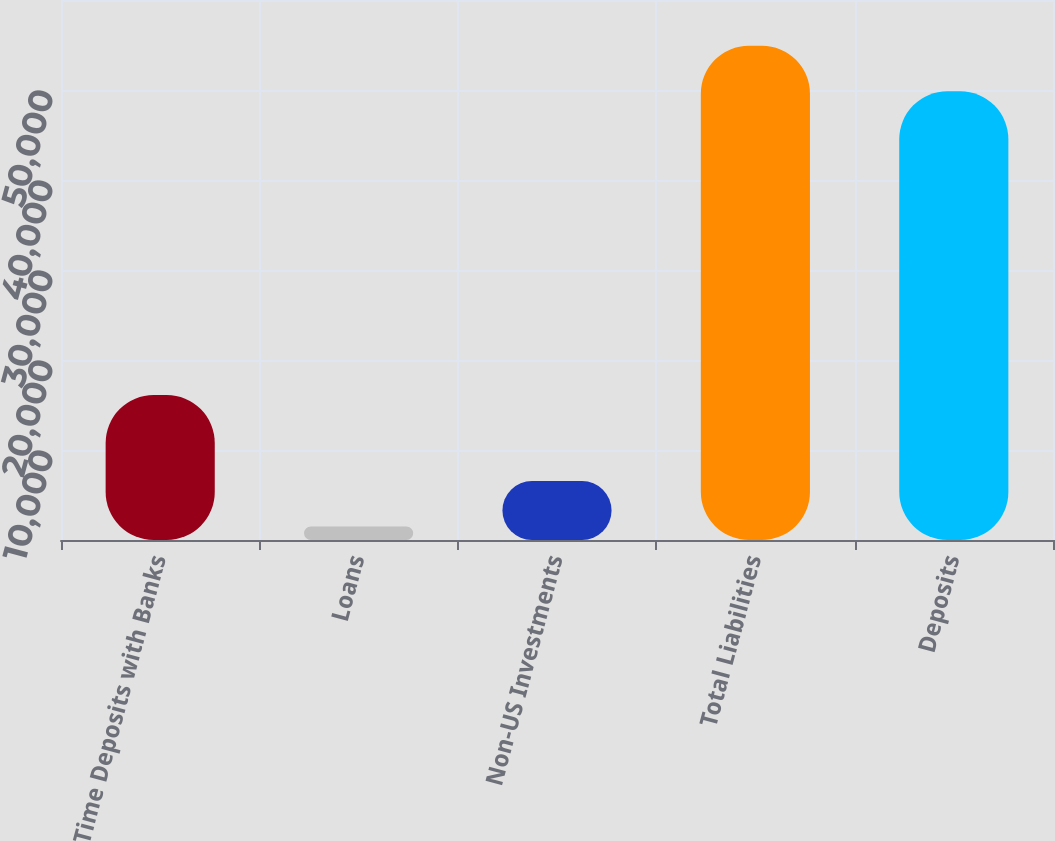Convert chart. <chart><loc_0><loc_0><loc_500><loc_500><bar_chart><fcel>Time Deposits with Banks<fcel>Loans<fcel>Non-US Investments<fcel>Total Liabilities<fcel>Deposits<nl><fcel>16106.9<fcel>1490.2<fcel>6553.51<fcel>54918<fcel>49854.7<nl></chart> 